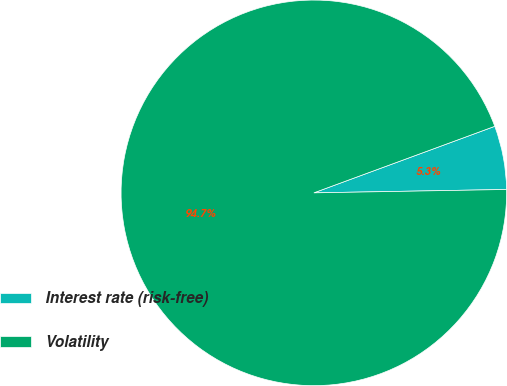<chart> <loc_0><loc_0><loc_500><loc_500><pie_chart><fcel>Interest rate (risk-free)<fcel>Volatility<nl><fcel>5.33%<fcel>94.67%<nl></chart> 